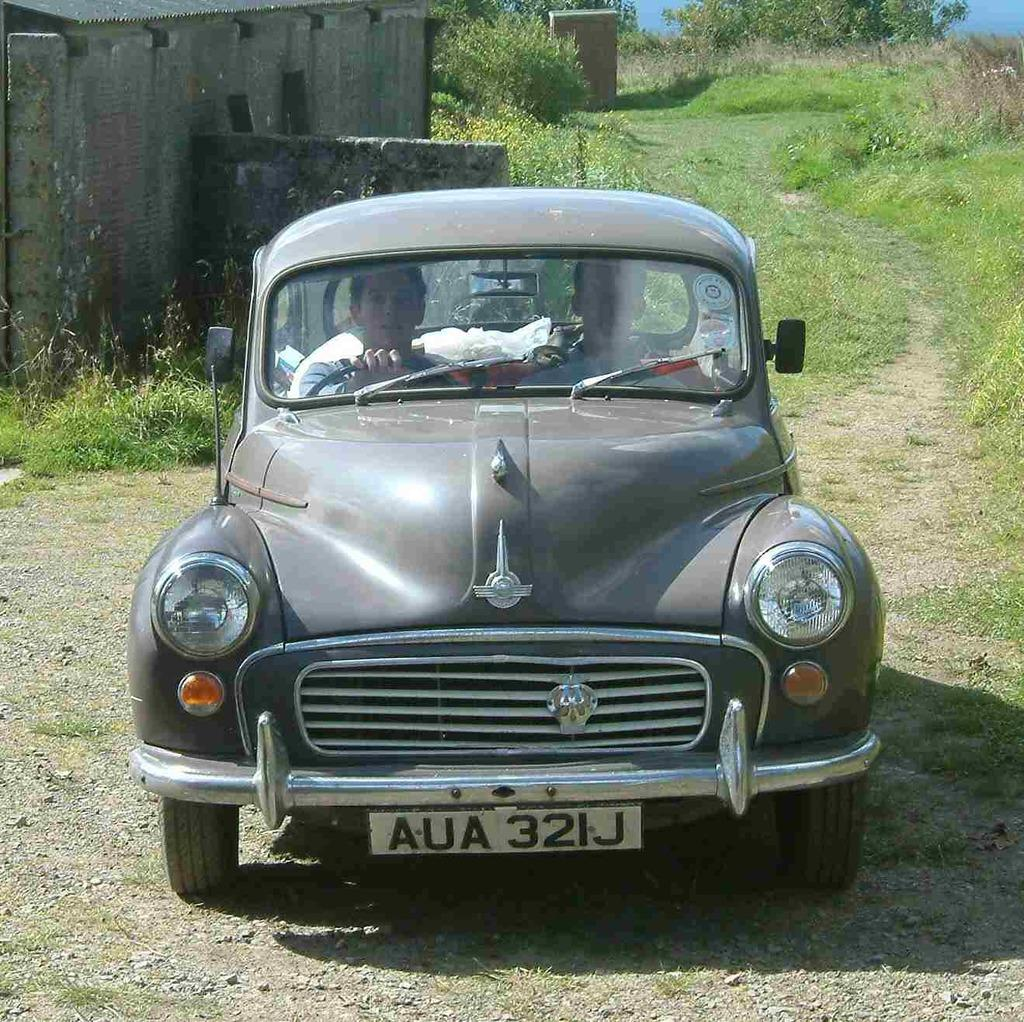What is the main subject in the middle of the image? There is a car in the middle of the image. Who or what is inside the car? Two persons are seated in the car. What can be seen in the background of the image? There is a house, grass, and trees in the background of the image. What type of chair is being used by the tree in the image? There is no tree or chair present in the image. What color is the tongue of the person in the car? There is no mention of a tongue or a person's tongue in the image. 